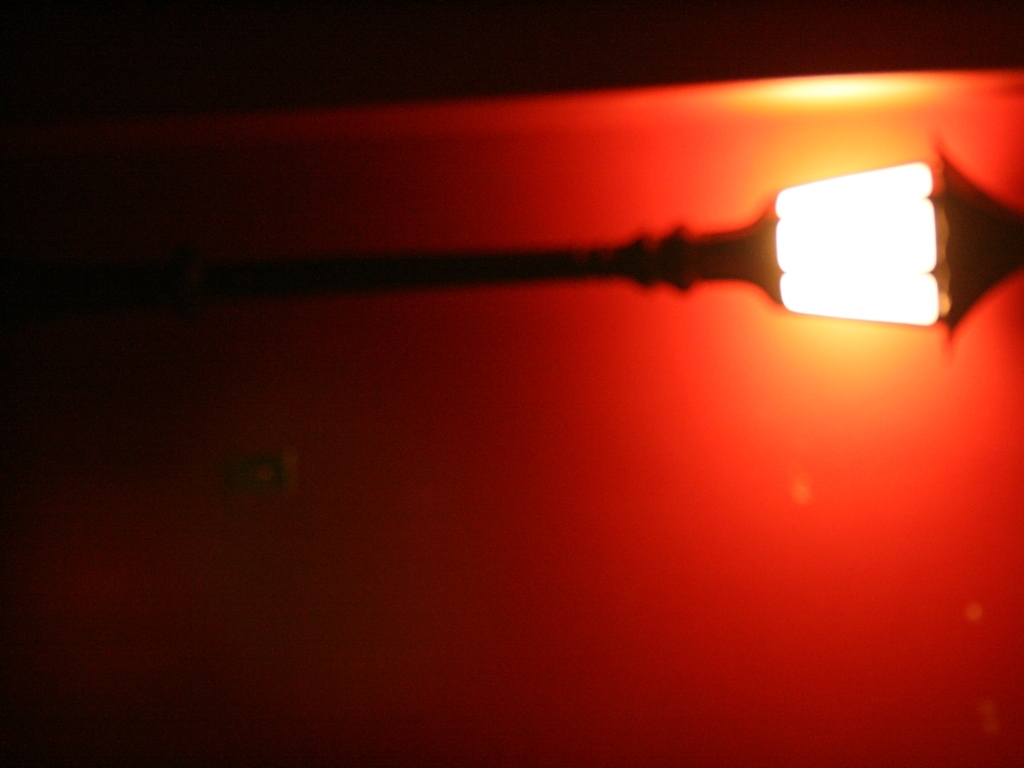What could be the source of light in this image, and what effect does it have on the picture? The source appears to be an artificial light, similar to a light bulb, encased within a translucent or frosted cover. Its bright glow casts a pervasive red, creating a dramatic contrast with surrounding shadows and resulting in a minimalistic yet bold composition. 